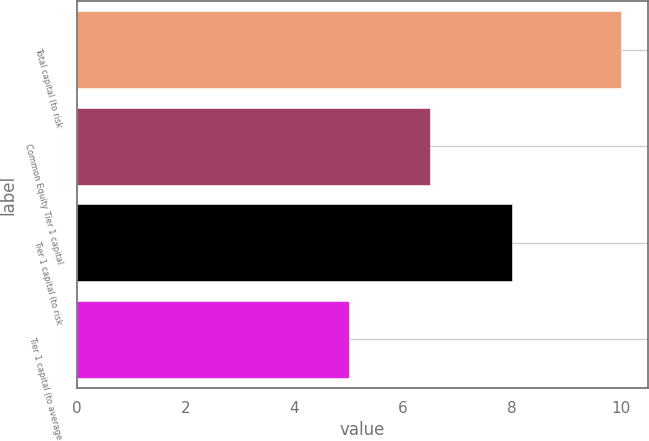Convert chart. <chart><loc_0><loc_0><loc_500><loc_500><bar_chart><fcel>Total capital (to risk<fcel>Common Equity Tier 1 capital<fcel>Tier 1 capital (to risk<fcel>Tier 1 capital (to average<nl><fcel>10<fcel>6.5<fcel>8<fcel>5<nl></chart> 